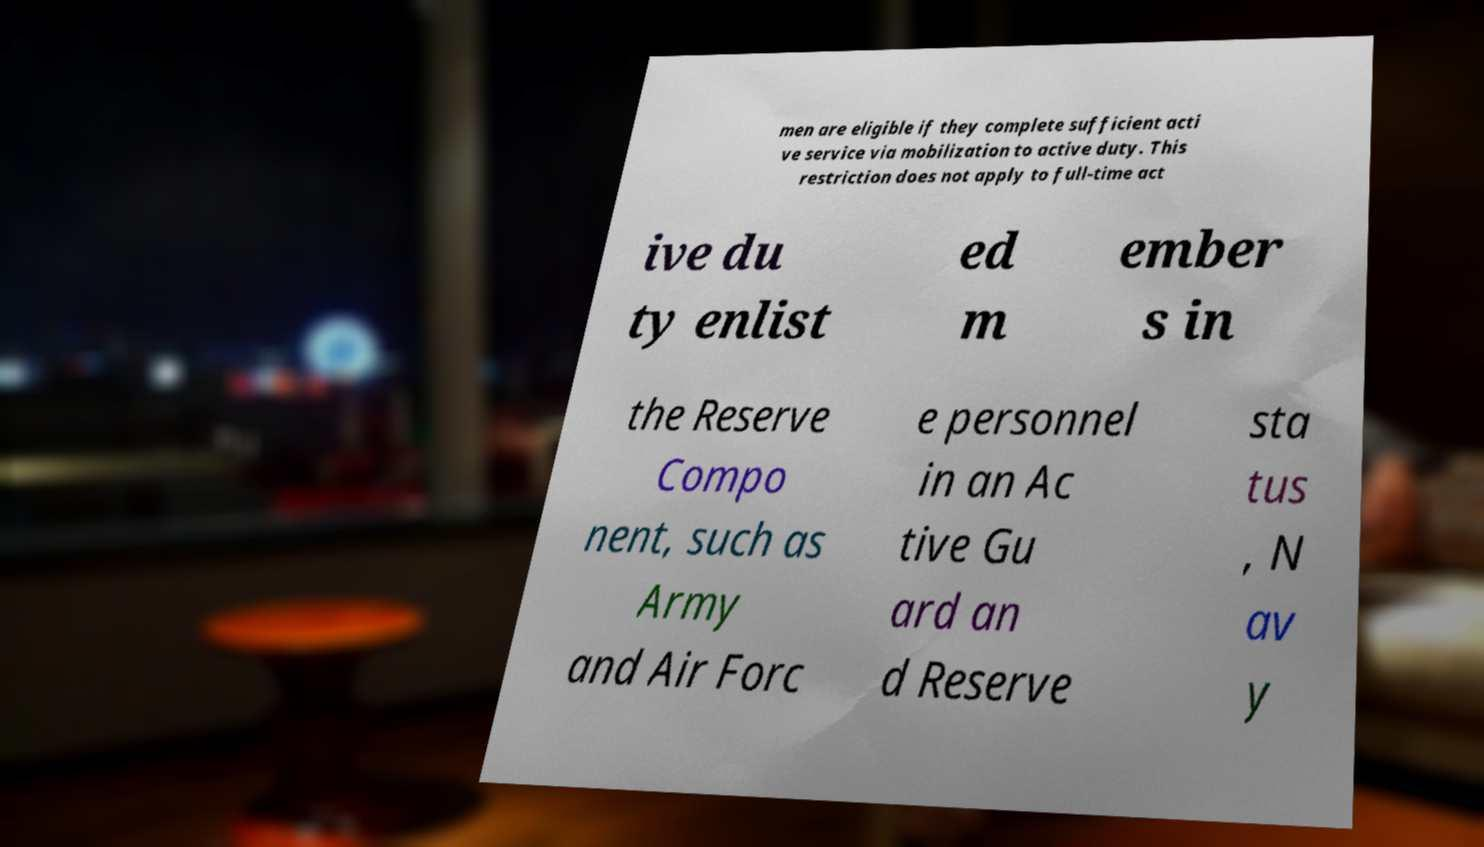Can you read and provide the text displayed in the image?This photo seems to have some interesting text. Can you extract and type it out for me? men are eligible if they complete sufficient acti ve service via mobilization to active duty. This restriction does not apply to full-time act ive du ty enlist ed m ember s in the Reserve Compo nent, such as Army and Air Forc e personnel in an Ac tive Gu ard an d Reserve sta tus , N av y 